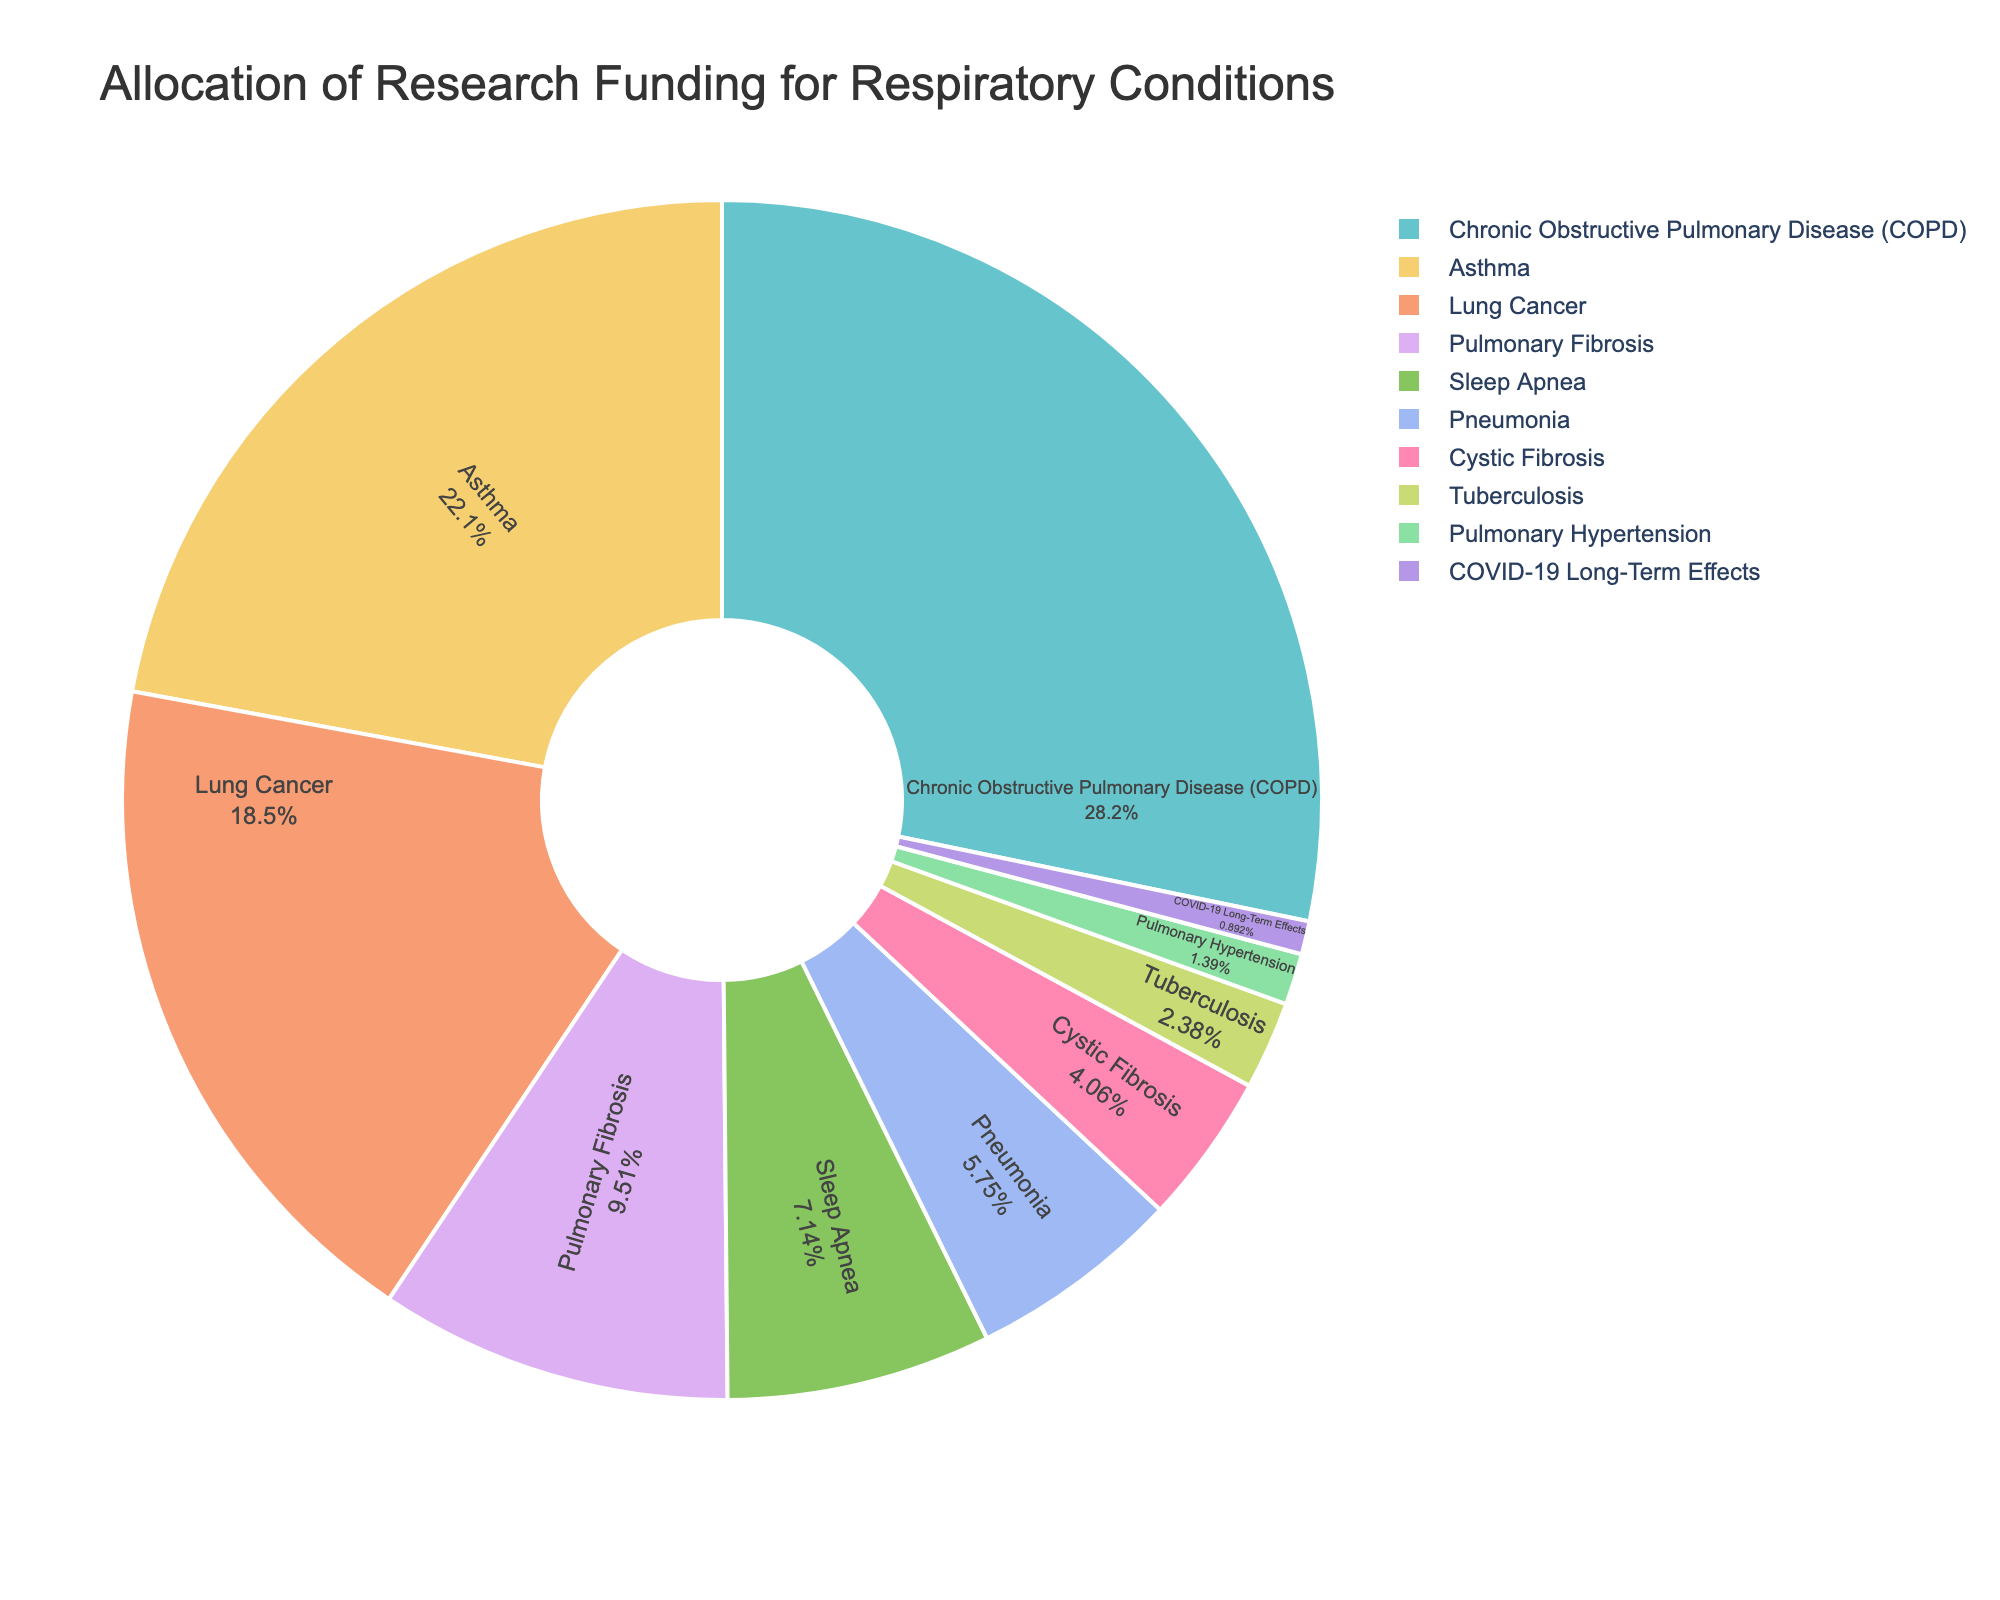What respiratory condition receives the highest percentage of research funding? The largest slice in the pie chart represents the condition that receives the highest percentage of research funding. It is labeled "Chronic Obstructive Pulmonary Disease (COPD)" with a funding percentage of 28.5%.
Answer: Chronic Obstructive Pulmonary Disease (COPD) Which condition has a larger funding percentage: Asthma or Lung Cancer? Compare the slices labeled "Asthma" and "Lung Cancer." The slice for Asthma is labeled 22.3%, while the slice for Lung Cancer is labeled 18.7%, indicating that Asthma has a higher funding percentage.
Answer: Asthma What is the sum of the funding percentages for Pulmonary Fibrosis and Sleep Apnea? Locate the slices for Pulmonary Fibrosis and Sleep Apnea. Pulmonary Fibrosis has a funding percentage of 9.6% and Sleep Apnea 7.2%. Adding these values gives 9.6 + 7.2 = 16.8.
Answer: 16.8% How much higher is the funding percentage for Asthma compared to Pneumonia? The Asthma slice shows 22.3%, and the Pneumonia slice shows 5.8%. Subtract the funding percentage of Pneumonia from that of Asthma: 22.3 - 5.8 = 16.5.
Answer: 16.5% Which condition receives the least amount of research funding? The smallest slice in the pie chart represents the condition with the least research funding. It is labeled "COVID-19 Long-Term Effects" with a funding percentage of 0.9%.
Answer: COVID-19 Long-Term Effects Is the sum of funding percentages for Cystic Fibrosis and Tuberculosis higher than that for Pneumonia? Check the funding percentages for Cystic Fibrosis (4.1%) and Tuberculosis (2.4%) and sum them: 4.1 + 2.4 = 6.5%. Compare this to the funding percentage of Pneumonia, which is 5.8%. Since 6.5 > 5.8, the sum is higher.
Answer: Yes How many conditions receive more than 10% of research funding? Locate all slices greater than 10%. COPD (28.5%), Asthma (22.3%), and Lung Cancer (18.7%) fall into this category. Count these conditions.
Answer: Three conditions What is the average funding percentage for the conditions receiving less than 5% funding? Identify the conditions with less than 5% funding: Cystic Fibrosis (4.1%), Tuberculosis (2.4%), Pulmonary Hypertension (1.4%), and COVID-19 Long-Term Effects (0.9%). Compute the average: (4.1 + 2.4 + 1.4 + 0.9) / 4 = 8.8 / 4 = 2.2.
Answer: 2.2% What is the combined funding percentage for conditions related to any fibrosis or hypertension? Locate the slices for Pulmonary Fibrosis (9.6%) and Pulmonary Hypertension (1.4%) and sum them: 9.6 + 1.4 = 11.0.
Answer: 11.0% Is the funding percentage for Lung Cancer closer to that of Asthma or Pneumonia? Lung Cancer is funded at 18.7%. Compare the differences: 22.3 - 18.7 = 3.6 (Asthma), 18.7 - 5.8 = 12.9 (Pneumonia). The difference with Asthma is smaller, indicating it is closer to Asthma.
Answer: Asthma 